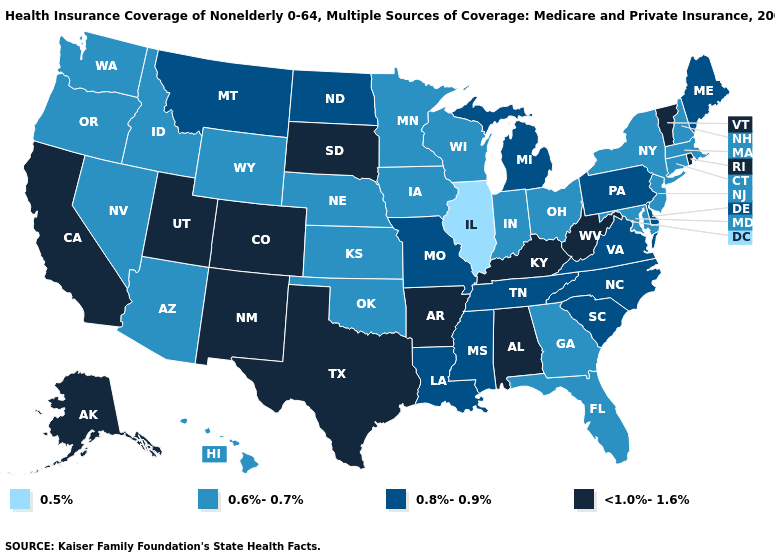Among the states that border Tennessee , does Missouri have the highest value?
Answer briefly. No. Which states have the lowest value in the MidWest?
Write a very short answer. Illinois. Name the states that have a value in the range <1.0%-1.6%?
Short answer required. Alabama, Alaska, Arkansas, California, Colorado, Kentucky, New Mexico, Rhode Island, South Dakota, Texas, Utah, Vermont, West Virginia. Does the map have missing data?
Answer briefly. No. What is the highest value in states that border Florida?
Answer briefly. <1.0%-1.6%. Does Maryland have the same value as Ohio?
Give a very brief answer. Yes. Name the states that have a value in the range 0.5%?
Be succinct. Illinois. Does Alabama have a lower value than Minnesota?
Give a very brief answer. No. Among the states that border New Mexico , does Oklahoma have the lowest value?
Keep it brief. Yes. Name the states that have a value in the range 0.8%-0.9%?
Keep it brief. Delaware, Louisiana, Maine, Michigan, Mississippi, Missouri, Montana, North Carolina, North Dakota, Pennsylvania, South Carolina, Tennessee, Virginia. Is the legend a continuous bar?
Give a very brief answer. No. Does Louisiana have the same value as New Jersey?
Write a very short answer. No. Does South Carolina have the lowest value in the USA?
Quick response, please. No. Does Idaho have the highest value in the West?
Concise answer only. No. 